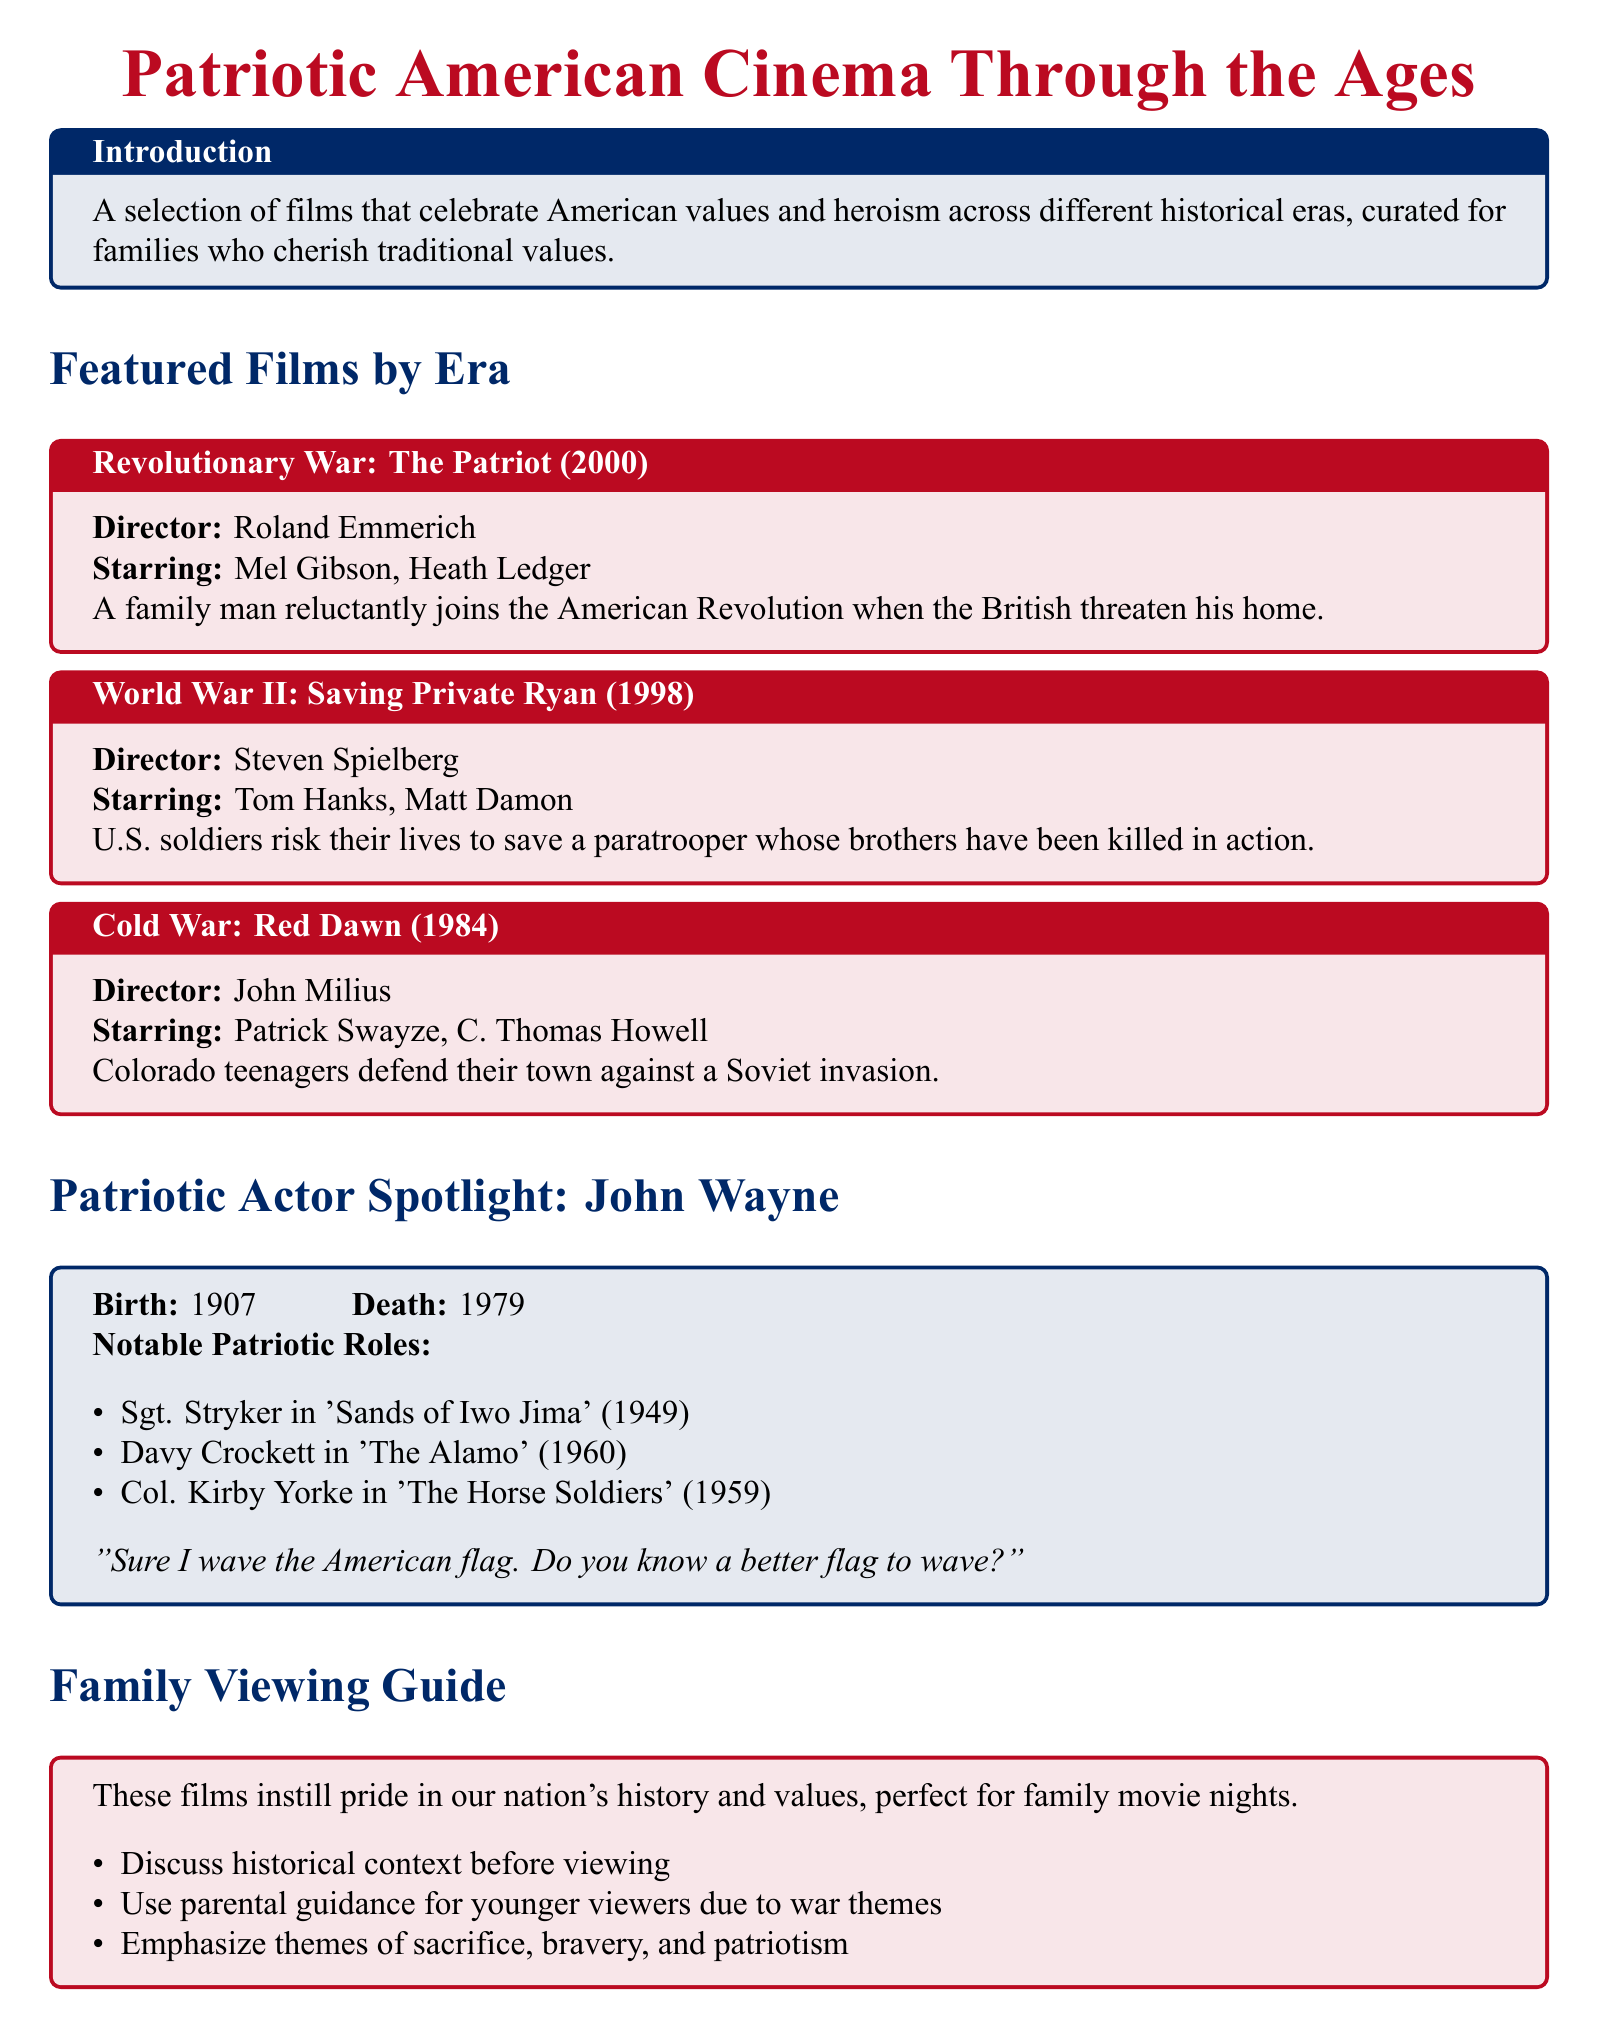What is the title of the film set during the Revolutionary War? The title of the film is provided under the Revolutionary War section of the document.
Answer: The Patriot (2000) Who directed "Saving Private Ryan"? The document mentions the director's name associated with the film "Saving Private Ryan."
Answer: Steven Spielberg Which actor played a role in "Red Dawn"? This question refers to the actor featured in the "Red Dawn" entry, as listed in the document.
Answer: Patrick Swayze What year was John Wayne born? The birth year of John Wayne is noted in the actor spotlight section.
Answer: 1907 What is a recommended viewing guide tip regarding younger viewers? The Family Viewing Guide section presents suggestions for family viewings related to younger audiences.
Answer: Use parental guidance What do the featured films instill in viewers according to the Family Viewing Guide? The document specifies what values the films instill in families as mentioned in the guide.
Answer: Pride Which patriotic role did John Wayne play in 1949? The document lists John Wayne's notable roles, including one from the year 1949.
Answer: Sgt. Stryker in 'Sands of Iwo Jima' How many notable patriotic roles are listed for John Wayne? The document counts the roles mentioned in John Wayne's biography section.
Answer: Three 